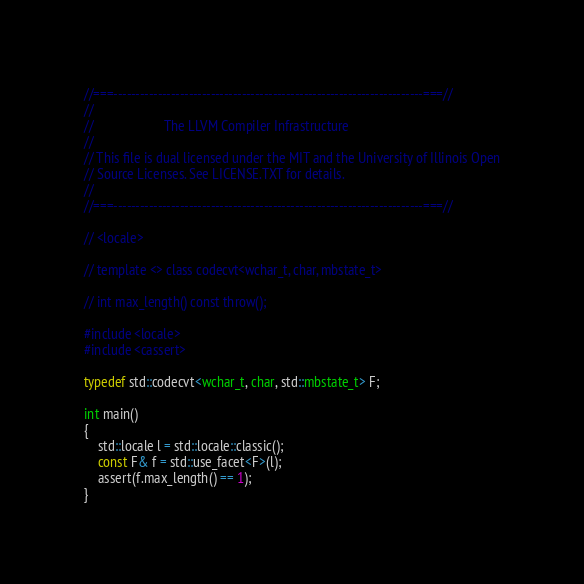<code> <loc_0><loc_0><loc_500><loc_500><_C++_>//===----------------------------------------------------------------------===//
//
//                     The LLVM Compiler Infrastructure
//
// This file is dual licensed under the MIT and the University of Illinois Open
// Source Licenses. See LICENSE.TXT for details.
//
//===----------------------------------------------------------------------===//

// <locale>

// template <> class codecvt<wchar_t, char, mbstate_t>

// int max_length() const throw();

#include <locale>
#include <cassert>

typedef std::codecvt<wchar_t, char, std::mbstate_t> F;

int main()
{
    std::locale l = std::locale::classic();
    const F& f = std::use_facet<F>(l);
    assert(f.max_length() == 1);
}
</code> 